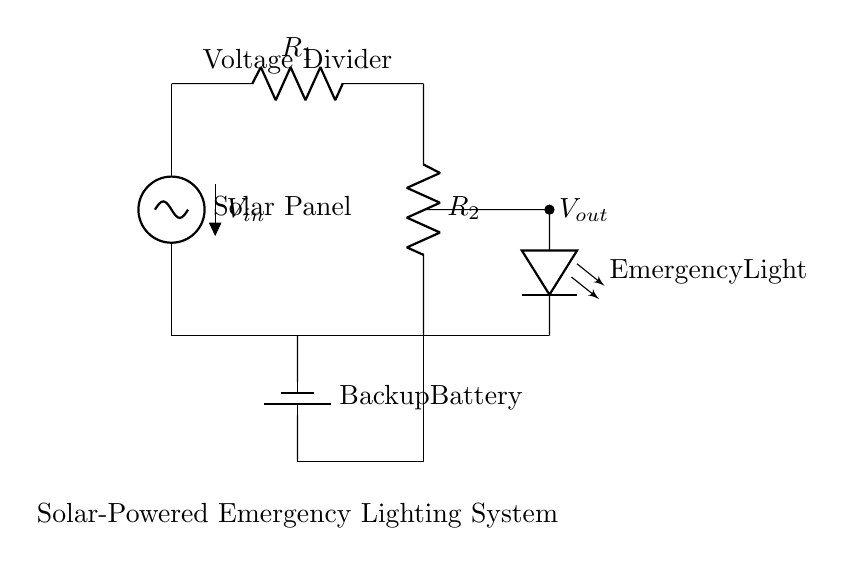What is the voltage input for this circuit? The voltage input, represented as V_in, is the voltage supplied by the solar panel at the top of the circuit.
Answer: V_in What component provides backup power? The backup power is provided by the backup battery, which is indicated in the diagram as a separate unit below the dividers.
Answer: Backup Battery What is the purpose of the voltage divider? The voltage divider is used to reduce the voltage from the solar panel to a lower level suitable for the emergency light.
Answer: Reduce voltage What is the output voltage of the voltage divider? The output voltage, labeled as V_out, is taken from the junction between the two resistors, R1 and R2, and is intended for the emergency lighting component.
Answer: V_out How many resistors are in the voltage divider? There are two resistors in the voltage divider circuit, R1 and R2, which are connected in series.
Answer: Two What type of light is connected to the output? The type of light connected to the output is an emergency light, represented in the diagram as a light-emitting diode (LED).
Answer: Emergency light What is the relationship between R1 and R2 in this circuit? R1 and R2 are in a series configuration; the resistances divide the input voltage according to their values. The voltage is split between them based on their resistance values.
Answer: Series configuration 